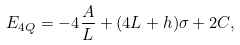Convert formula to latex. <formula><loc_0><loc_0><loc_500><loc_500>E _ { 4 Q } = - 4 \frac { A } { L } + ( 4 L + h ) \sigma + 2 C ,</formula> 